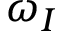<formula> <loc_0><loc_0><loc_500><loc_500>\omega _ { I }</formula> 